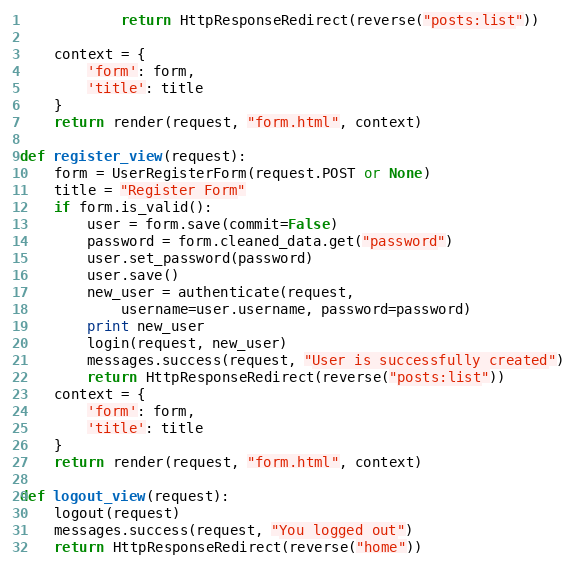<code> <loc_0><loc_0><loc_500><loc_500><_Python_>            return HttpResponseRedirect(reverse("posts:list"))

    context = {
        'form': form,
        'title': title
    }
    return render(request, "form.html", context)

def register_view(request):
    form = UserRegisterForm(request.POST or None)
    title = "Register Form"
    if form.is_valid():
        user = form.save(commit=False)
        password = form.cleaned_data.get("password")
        user.set_password(password)
        user.save()
        new_user = authenticate(request,
            username=user.username, password=password)
        print new_user
        login(request, new_user)
        messages.success(request, "User is successfully created")
        return HttpResponseRedirect(reverse("posts:list"))
    context = {
        'form': form,
        'title': title
    }
    return render(request, "form.html", context)

def logout_view(request):
    logout(request)
    messages.success(request, "You logged out")
    return HttpResponseRedirect(reverse("home"))</code> 